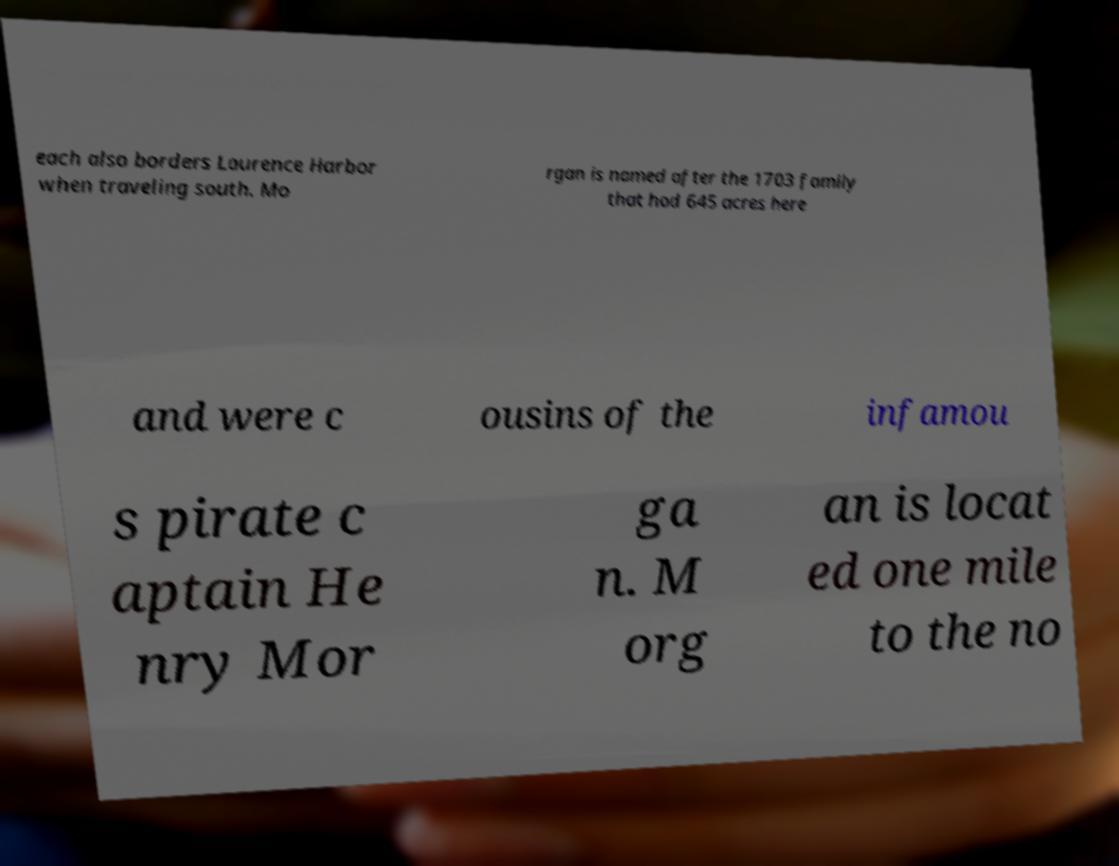Could you extract and type out the text from this image? each also borders Laurence Harbor when traveling south. Mo rgan is named after the 1703 family that had 645 acres here and were c ousins of the infamou s pirate c aptain He nry Mor ga n. M org an is locat ed one mile to the no 